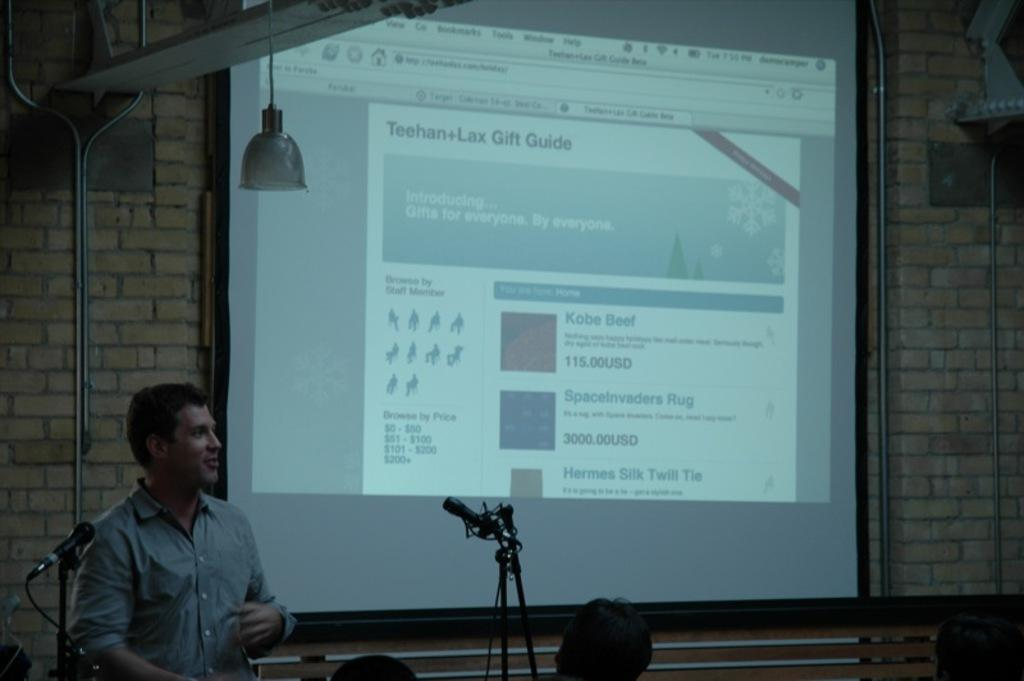What is the main object in the image? There is a projector screen in the image. Where is the person located in the image? The person is on the left side of the image. What can be seen besides the projector screen and the person? There are microphones visible in the image. Reasoning: Let's think step by following the guidelines to produce the conversation. We start by identifying the main object in the image, which is the projector screen. Then, we describe the location of the person in the image, which is on the left side. Finally, we mention the presence of microphones as additional items visible in the image. Absurd Question/Answer: What is the manager's role in the image? There is no mention of a manager in the image, so we cannot determine their role. 